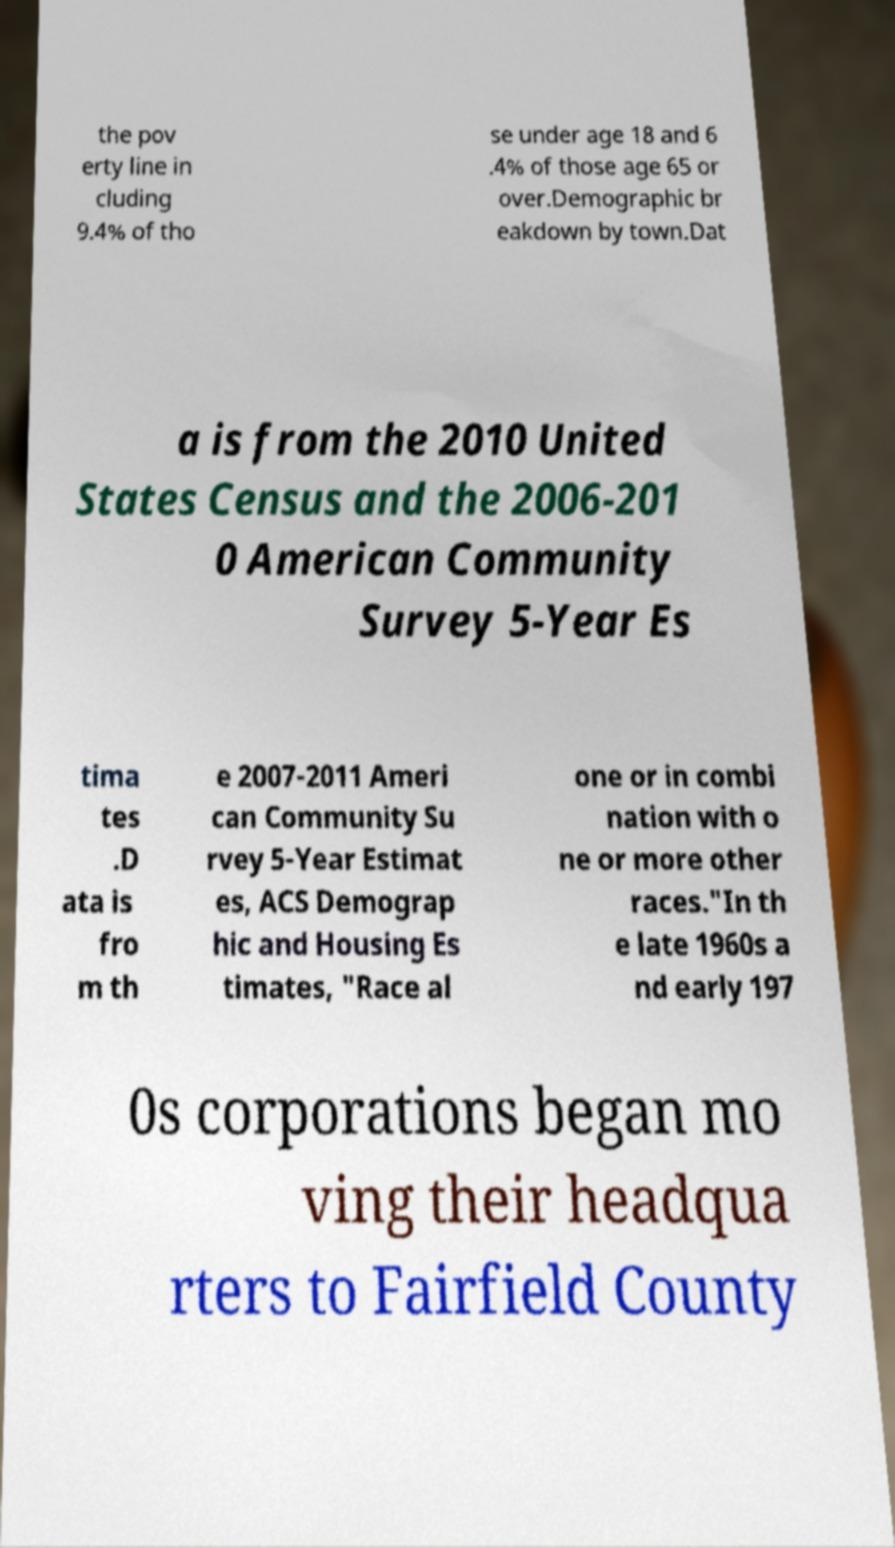I need the written content from this picture converted into text. Can you do that? the pov erty line in cluding 9.4% of tho se under age 18 and 6 .4% of those age 65 or over.Demographic br eakdown by town.Dat a is from the 2010 United States Census and the 2006-201 0 American Community Survey 5-Year Es tima tes .D ata is fro m th e 2007-2011 Ameri can Community Su rvey 5-Year Estimat es, ACS Demograp hic and Housing Es timates, "Race al one or in combi nation with o ne or more other races."In th e late 1960s a nd early 197 0s corporations began mo ving their headqua rters to Fairfield County 